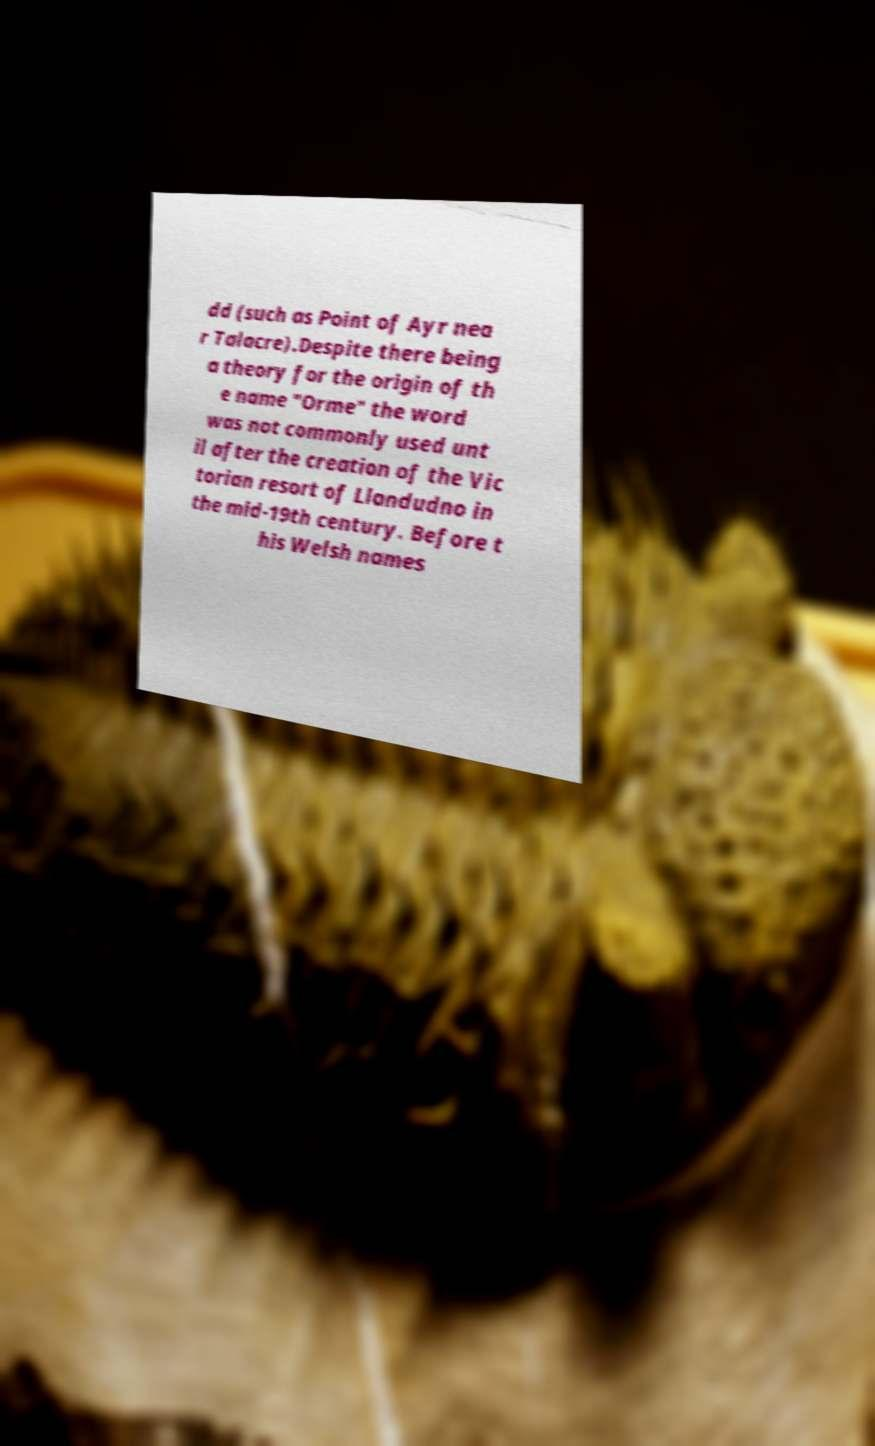Can you accurately transcribe the text from the provided image for me? dd (such as Point of Ayr nea r Talacre).Despite there being a theory for the origin of th e name "Orme" the word was not commonly used unt il after the creation of the Vic torian resort of Llandudno in the mid-19th century. Before t his Welsh names 